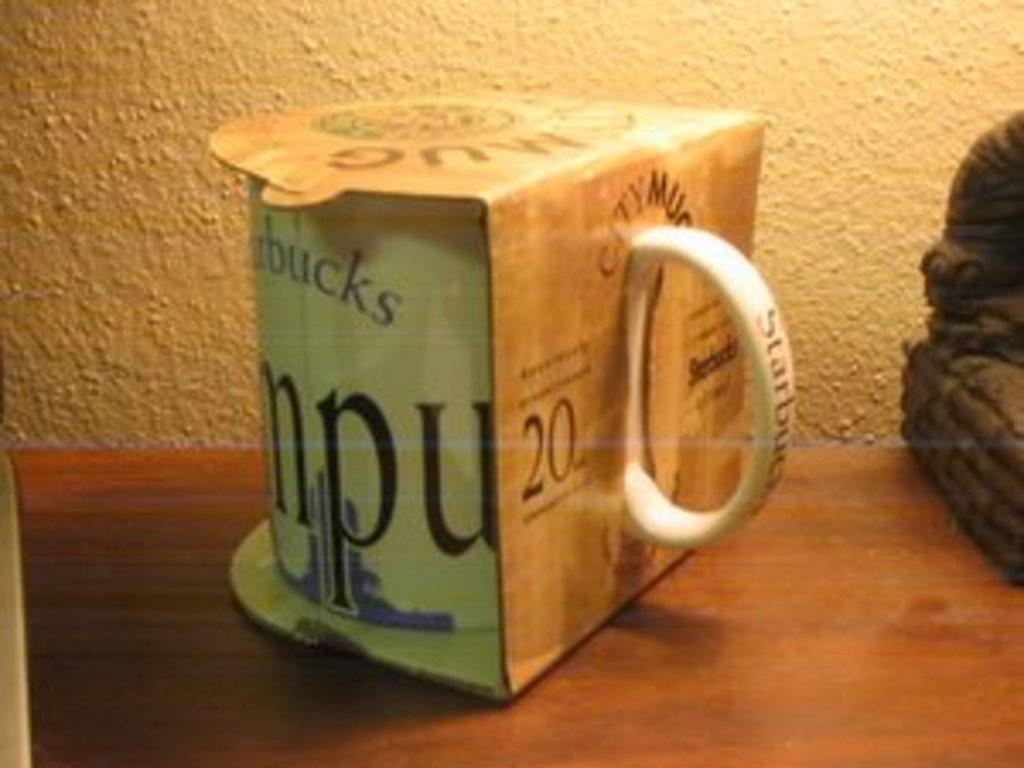<image>
Give a short and clear explanation of the subsequent image. starbucks's city mug in its packaging on a wooden surface 